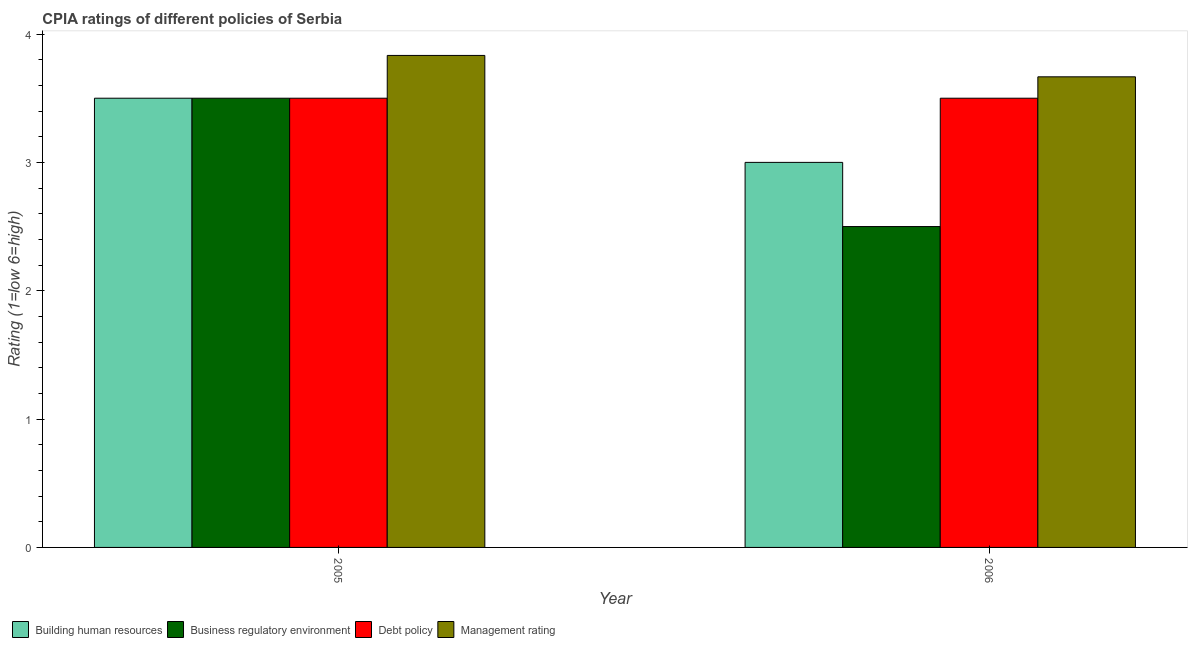How many groups of bars are there?
Offer a very short reply. 2. How many bars are there on the 2nd tick from the right?
Ensure brevity in your answer.  4. What is the cpia rating of management in 2006?
Provide a short and direct response. 3.67. Across all years, what is the minimum cpia rating of business regulatory environment?
Make the answer very short. 2.5. In which year was the cpia rating of building human resources maximum?
Ensure brevity in your answer.  2005. What is the total cpia rating of business regulatory environment in the graph?
Offer a terse response. 6. What is the difference between the cpia rating of management in 2005 and the cpia rating of debt policy in 2006?
Make the answer very short. 0.17. In the year 2006, what is the difference between the cpia rating of management and cpia rating of debt policy?
Offer a terse response. 0. In how many years, is the cpia rating of building human resources greater than 0.8?
Make the answer very short. 2. What is the ratio of the cpia rating of debt policy in 2005 to that in 2006?
Give a very brief answer. 1. What does the 1st bar from the left in 2006 represents?
Provide a short and direct response. Building human resources. What does the 1st bar from the right in 2006 represents?
Your response must be concise. Management rating. Is it the case that in every year, the sum of the cpia rating of building human resources and cpia rating of business regulatory environment is greater than the cpia rating of debt policy?
Give a very brief answer. Yes. Are all the bars in the graph horizontal?
Provide a succinct answer. No. How many years are there in the graph?
Offer a terse response. 2. Are the values on the major ticks of Y-axis written in scientific E-notation?
Your answer should be very brief. No. Does the graph contain any zero values?
Keep it short and to the point. No. Where does the legend appear in the graph?
Ensure brevity in your answer.  Bottom left. What is the title of the graph?
Your answer should be compact. CPIA ratings of different policies of Serbia. What is the Rating (1=low 6=high) of Business regulatory environment in 2005?
Provide a short and direct response. 3.5. What is the Rating (1=low 6=high) of Management rating in 2005?
Offer a terse response. 3.83. What is the Rating (1=low 6=high) in Building human resources in 2006?
Provide a short and direct response. 3. What is the Rating (1=low 6=high) in Debt policy in 2006?
Provide a succinct answer. 3.5. What is the Rating (1=low 6=high) of Management rating in 2006?
Make the answer very short. 3.67. Across all years, what is the maximum Rating (1=low 6=high) of Building human resources?
Your answer should be very brief. 3.5. Across all years, what is the maximum Rating (1=low 6=high) of Management rating?
Give a very brief answer. 3.83. Across all years, what is the minimum Rating (1=low 6=high) of Building human resources?
Offer a terse response. 3. Across all years, what is the minimum Rating (1=low 6=high) in Business regulatory environment?
Your response must be concise. 2.5. Across all years, what is the minimum Rating (1=low 6=high) in Debt policy?
Your response must be concise. 3.5. Across all years, what is the minimum Rating (1=low 6=high) in Management rating?
Your answer should be compact. 3.67. What is the total Rating (1=low 6=high) in Business regulatory environment in the graph?
Offer a terse response. 6. What is the total Rating (1=low 6=high) of Debt policy in the graph?
Keep it short and to the point. 7. What is the total Rating (1=low 6=high) of Management rating in the graph?
Ensure brevity in your answer.  7.5. What is the difference between the Rating (1=low 6=high) in Building human resources in 2005 and that in 2006?
Keep it short and to the point. 0.5. What is the difference between the Rating (1=low 6=high) of Business regulatory environment in 2005 and that in 2006?
Ensure brevity in your answer.  1. What is the difference between the Rating (1=low 6=high) of Management rating in 2005 and that in 2006?
Offer a terse response. 0.17. What is the difference between the Rating (1=low 6=high) of Building human resources in 2005 and the Rating (1=low 6=high) of Business regulatory environment in 2006?
Make the answer very short. 1. What is the difference between the Rating (1=low 6=high) of Building human resources in 2005 and the Rating (1=low 6=high) of Debt policy in 2006?
Offer a terse response. 0. What is the difference between the Rating (1=low 6=high) of Business regulatory environment in 2005 and the Rating (1=low 6=high) of Debt policy in 2006?
Offer a very short reply. 0. What is the average Rating (1=low 6=high) in Business regulatory environment per year?
Provide a short and direct response. 3. What is the average Rating (1=low 6=high) of Management rating per year?
Offer a very short reply. 3.75. In the year 2005, what is the difference between the Rating (1=low 6=high) of Building human resources and Rating (1=low 6=high) of Management rating?
Provide a short and direct response. -0.33. In the year 2006, what is the difference between the Rating (1=low 6=high) of Building human resources and Rating (1=low 6=high) of Business regulatory environment?
Your answer should be very brief. 0.5. In the year 2006, what is the difference between the Rating (1=low 6=high) of Building human resources and Rating (1=low 6=high) of Debt policy?
Keep it short and to the point. -0.5. In the year 2006, what is the difference between the Rating (1=low 6=high) in Building human resources and Rating (1=low 6=high) in Management rating?
Offer a very short reply. -0.67. In the year 2006, what is the difference between the Rating (1=low 6=high) in Business regulatory environment and Rating (1=low 6=high) in Debt policy?
Give a very brief answer. -1. In the year 2006, what is the difference between the Rating (1=low 6=high) in Business regulatory environment and Rating (1=low 6=high) in Management rating?
Your response must be concise. -1.17. In the year 2006, what is the difference between the Rating (1=low 6=high) in Debt policy and Rating (1=low 6=high) in Management rating?
Your answer should be compact. -0.17. What is the ratio of the Rating (1=low 6=high) of Management rating in 2005 to that in 2006?
Your answer should be compact. 1.05. What is the difference between the highest and the second highest Rating (1=low 6=high) of Building human resources?
Your answer should be compact. 0.5. What is the difference between the highest and the lowest Rating (1=low 6=high) in Building human resources?
Keep it short and to the point. 0.5. What is the difference between the highest and the lowest Rating (1=low 6=high) of Management rating?
Make the answer very short. 0.17. 